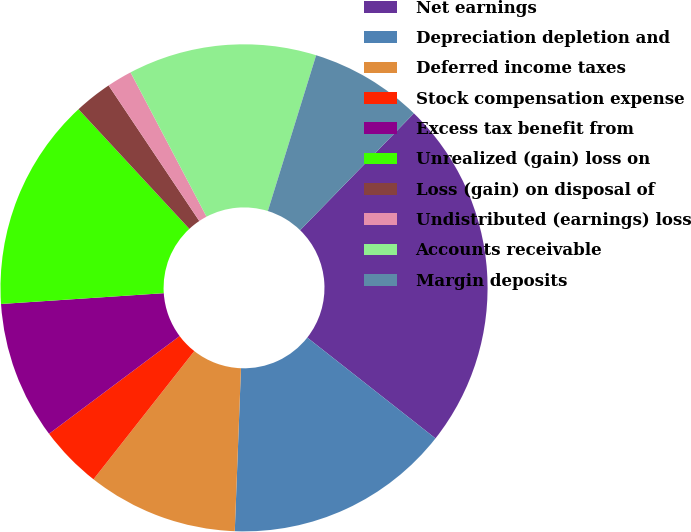<chart> <loc_0><loc_0><loc_500><loc_500><pie_chart><fcel>Net earnings<fcel>Depreciation depletion and<fcel>Deferred income taxes<fcel>Stock compensation expense<fcel>Excess tax benefit from<fcel>Unrealized (gain) loss on<fcel>Loss (gain) on disposal of<fcel>Undistributed (earnings) loss<fcel>Accounts receivable<fcel>Margin deposits<nl><fcel>23.32%<fcel>15.0%<fcel>10.0%<fcel>4.17%<fcel>9.17%<fcel>14.16%<fcel>2.51%<fcel>1.67%<fcel>12.5%<fcel>7.5%<nl></chart> 